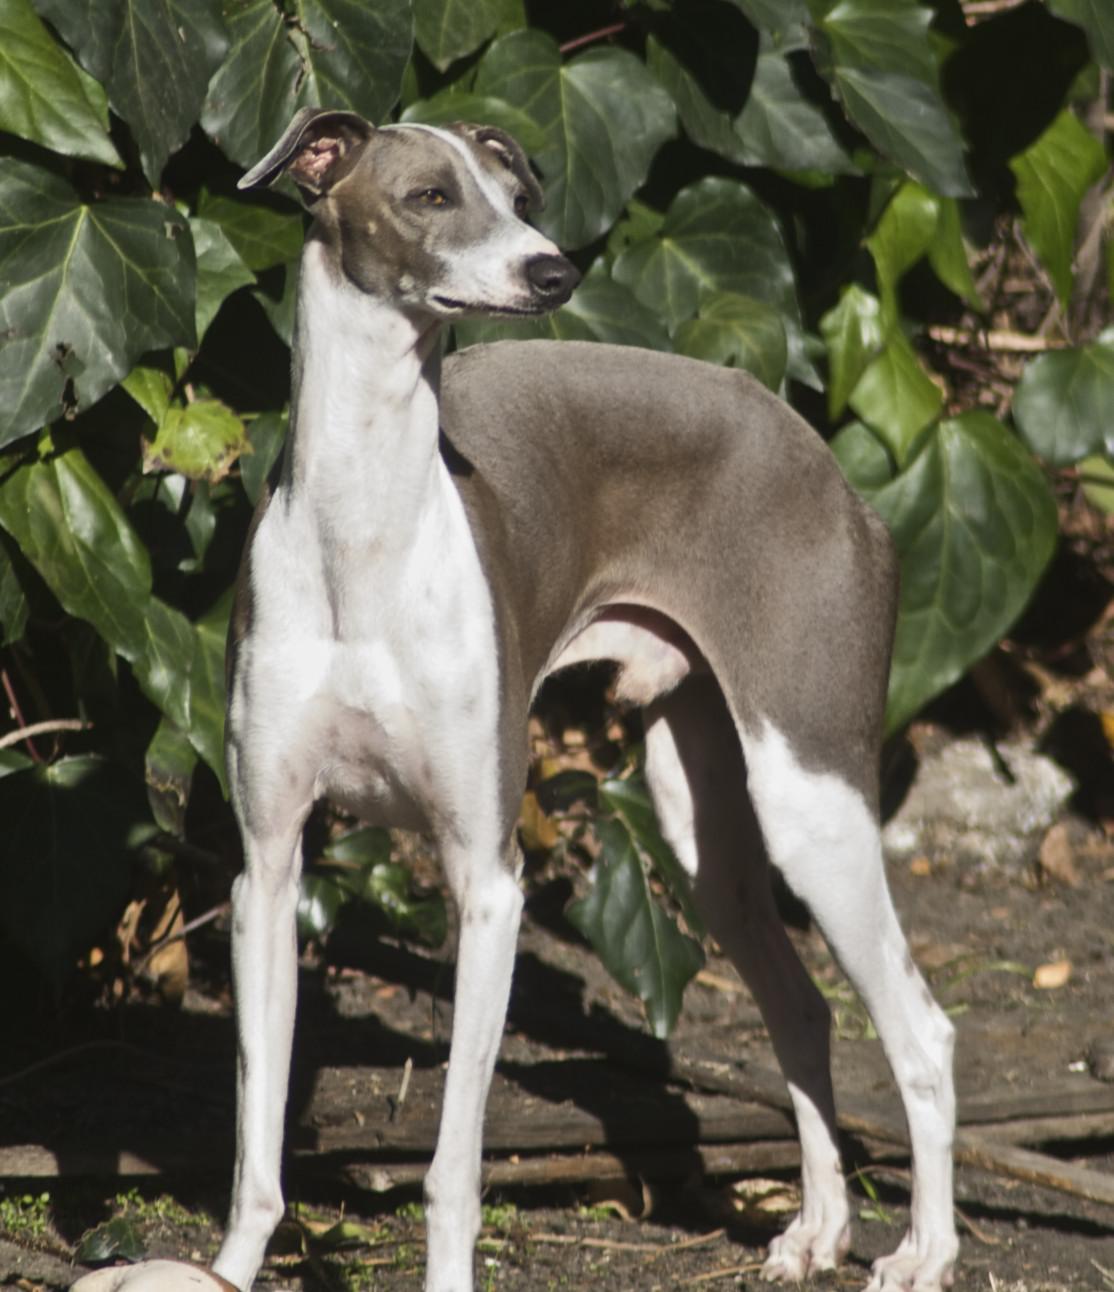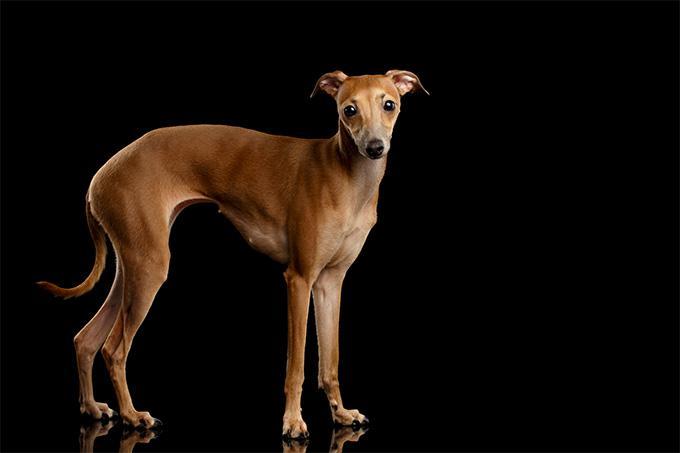The first image is the image on the left, the second image is the image on the right. For the images displayed, is the sentence "there is a gray dog standing with its body facing right" factually correct? Answer yes or no. No. 